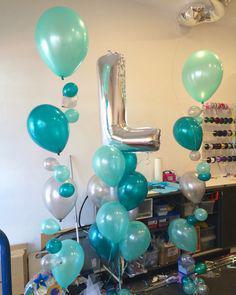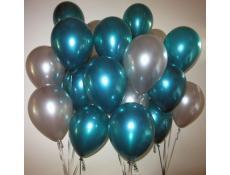The first image is the image on the left, the second image is the image on the right. Considering the images on both sides, is "there are plastick baloon holders insteas of ribbons" valid? Answer yes or no. No. 